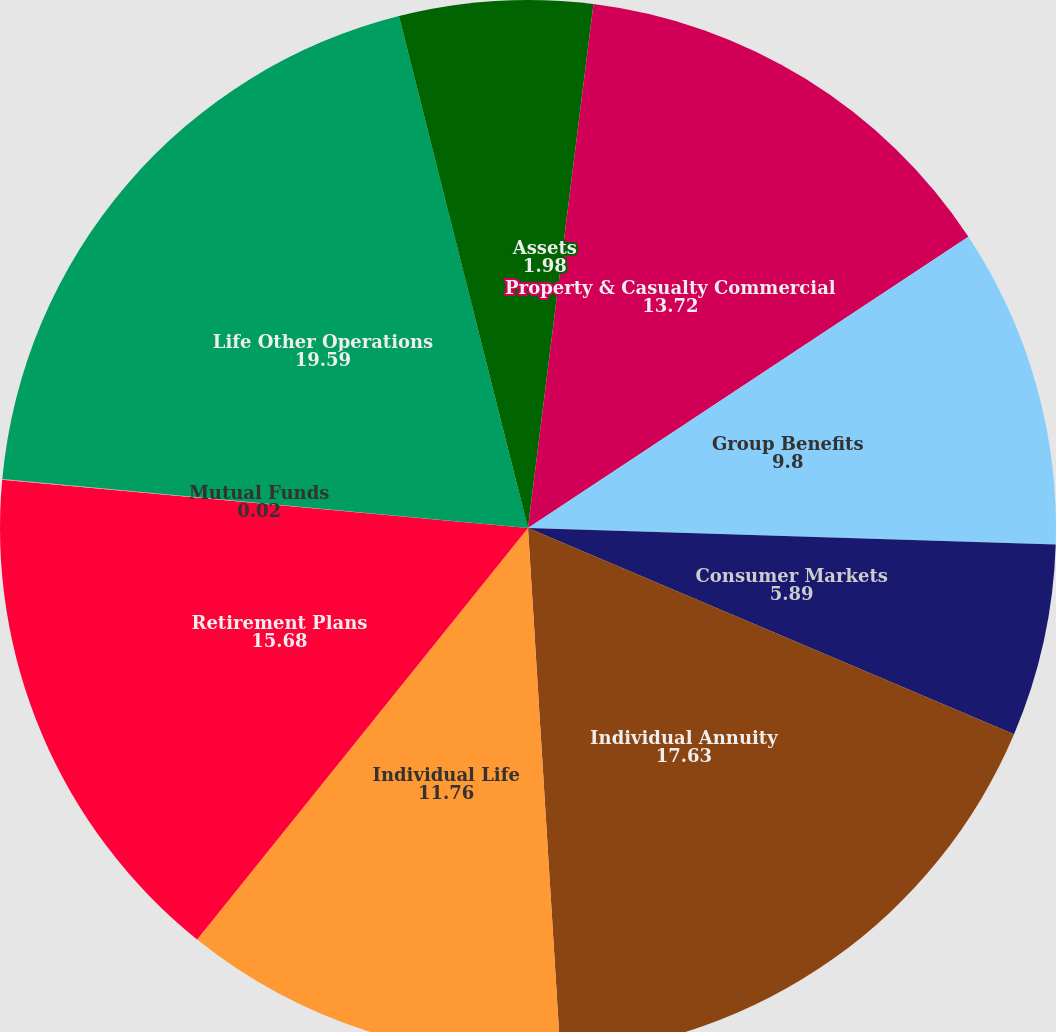<chart> <loc_0><loc_0><loc_500><loc_500><pie_chart><fcel>Assets<fcel>Property & Casualty Commercial<fcel>Group Benefits<fcel>Consumer Markets<fcel>Individual Annuity<fcel>Individual Life<fcel>Retirement Plans<fcel>Mutual Funds<fcel>Life Other Operations<fcel>Property & Casualty Other<nl><fcel>1.98%<fcel>13.72%<fcel>9.8%<fcel>5.89%<fcel>17.63%<fcel>11.76%<fcel>15.68%<fcel>0.02%<fcel>19.59%<fcel>3.93%<nl></chart> 